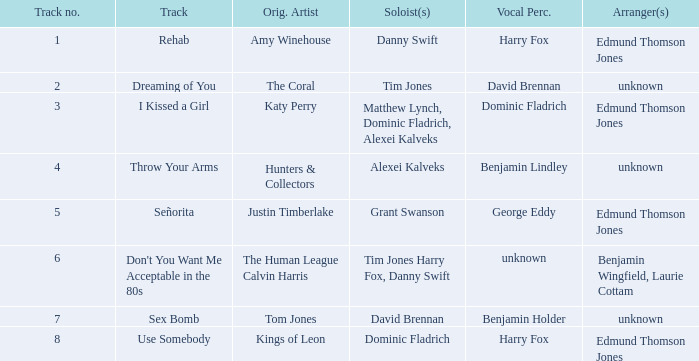Who is the original artist of "Use Somebody"? Kings of Leon. 